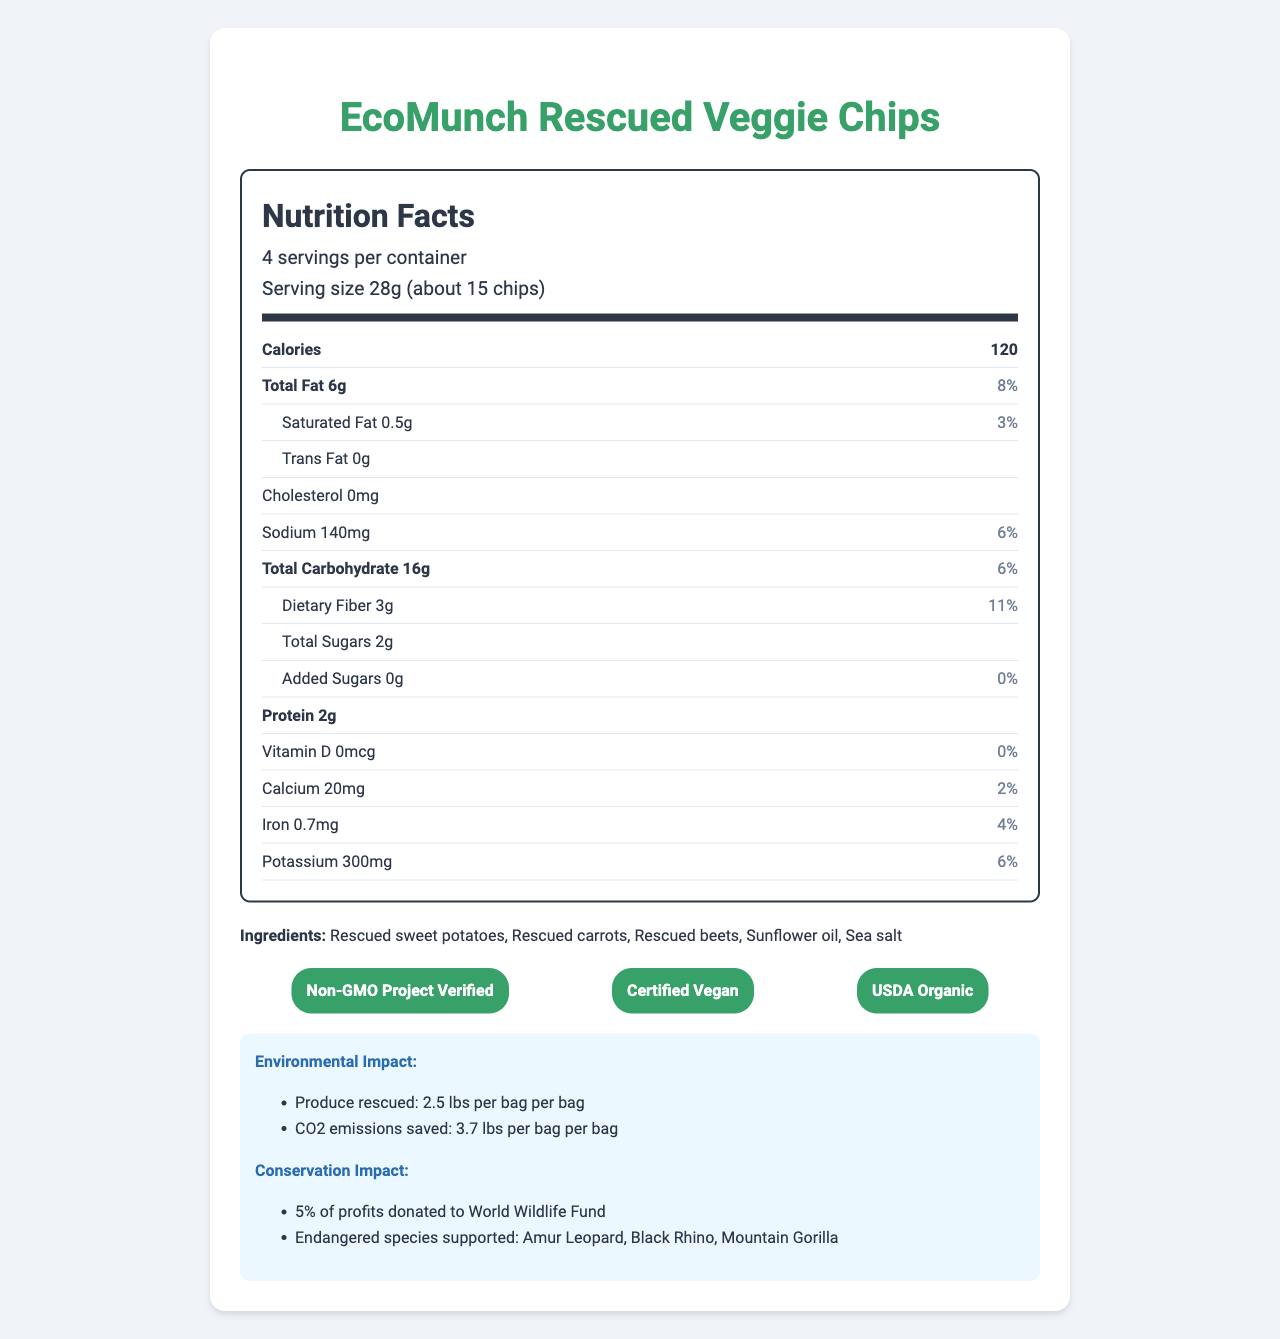what is the serving size of EcoMunch Rescued Veggie Chips? The serving size is clearly stated in the nutrition label as "28g (about 15 chips)".
Answer: 28g (about 15 chips) how many servings are there per container? The document states that there are "4 servings per container".
Answer: 4 how many grams of total fat are there per serving? In the nutrition facts section, the total fat content per serving is listed as 6g.
Answer: 6g what certification labels does the product have? These certifications are displayed in the certifications section of the document.
Answer: Non-GMO Project Verified, Certified Vegan, USDA Organic how many grams of added sugars are in a serving? The added sugars content per serving is listed as 0g in the nutrition facts.
Answer: 0g how many calories are there per serving? The document lists the calorie content per serving as 120 calories.
Answer: 120 what percentage of the daily iron value does a serving provide? The nutrition label indicates that a serving provides 4% of the daily value for iron.
Answer: 4% which of the following endangered species are NOT supported by EcoMunch Rescued Veggie Chips' profits? A. Amur Leopard B. Black Rhino C. Giant Panda D. Mountain Gorilla The document specifies that 5% of profits are donated to support Amur Leopard, Black Rhino, and Mountain Gorilla, but does not mention the Giant Panda.
Answer: C. Giant Panda what is the sodium content per serving in milligrams? A. 120mg B. 140mg C. 160mg D. 180mg The nutrition facts section lists the sodium content per serving as 140mg.
Answer: B. 140mg is the product packaging designed to be compostable? The document mentions that the packaging is 100% compostable and made from plant-based materials.
Answer: Yes describe the main idea of the document. The main idea of the document encompasses the nutritional details and environmental and conservation impacts of the EcoMunch Rescued Veggie Chips, highlighting their unique aspects and benefits.
Answer: The document provides detailed information about the EcoMunch Rescued Veggie Chips, emphasizing their nutritional facts, ingredients, certifications, environmental impact, and conservation efforts. The product is made from rescued produce to reduce food waste and is certified Non-GMO, Vegan, and Organic. The packaging is compostable, and 5% of profits support the conservation of endangered species like the Amur Leopard, Black Rhino, and Mountain Gorilla. how many grams of dietary fiber are there in a serving? The dietary fiber content per serving is listed as 3g in the nutrition facts section.
Answer: 3g what percentage of the daily value of potassium does a serving provide? The nutrition label indicates that a serving provides 6% of the daily value for potassium.
Answer: 6% are there any allergens in the product? The document mentions that the product is produced in a facility that processes tree nuts and soy.
Answer: Produced in a facility that also processes tree nuts and soy how much sweetener is added to the product? The document specifies that there are 2g of total sugars and 0g of added sugars but does not clarify whether those sugars are naturally occurring or added during production. Thus, we cannot determine the exact amount of sweetener used.
Answer: Not enough information 